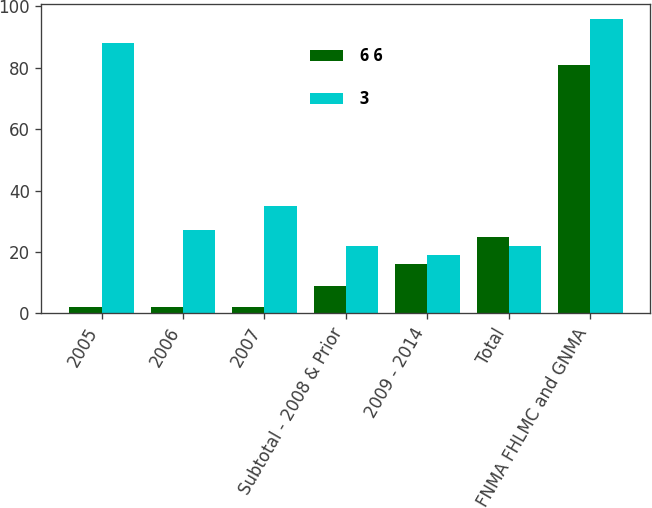<chart> <loc_0><loc_0><loc_500><loc_500><stacked_bar_chart><ecel><fcel>2005<fcel>2006<fcel>2007<fcel>Subtotal - 2008 & Prior<fcel>2009 - 2014<fcel>Total<fcel>FNMA FHLMC and GNMA<nl><fcel>6 6<fcel>2<fcel>2<fcel>2<fcel>9<fcel>16<fcel>25<fcel>81<nl><fcel>3<fcel>88<fcel>27<fcel>35<fcel>22<fcel>19<fcel>22<fcel>96<nl></chart> 